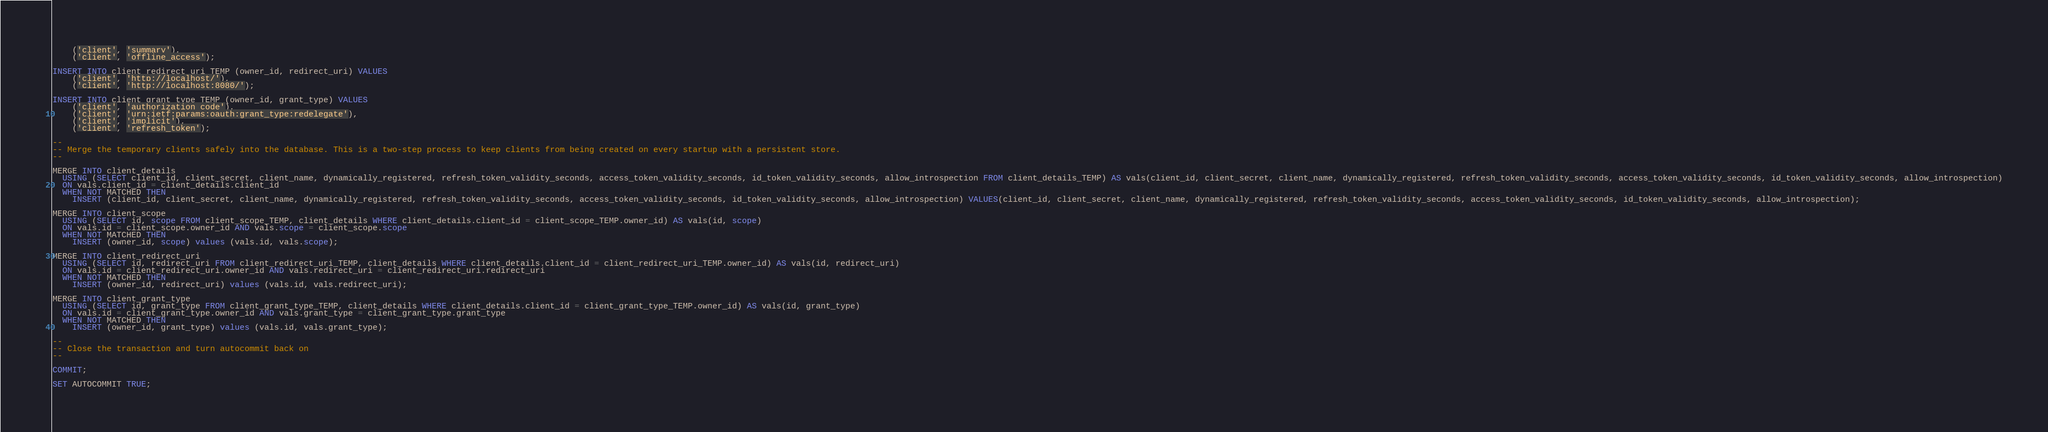Convert code to text. <code><loc_0><loc_0><loc_500><loc_500><_SQL_>	('client', 'summary'),
	('client', 'offline_access');

INSERT INTO client_redirect_uri_TEMP (owner_id, redirect_uri) VALUES
	('client', 'http://localhost/'),
	('client', 'http://localhost:8080/');
	
INSERT INTO client_grant_type_TEMP (owner_id, grant_type) VALUES
	('client', 'authorization_code'),
	('client', 'urn:ietf:params:oauth:grant_type:redelegate'),
	('client', 'implicit'),
	('client', 'refresh_token');
	
--
-- Merge the temporary clients safely into the database. This is a two-step process to keep clients from being created on every startup with a persistent store.
--

MERGE INTO client_details 
  USING (SELECT client_id, client_secret, client_name, dynamically_registered, refresh_token_validity_seconds, access_token_validity_seconds, id_token_validity_seconds, allow_introspection FROM client_details_TEMP) AS vals(client_id, client_secret, client_name, dynamically_registered, refresh_token_validity_seconds, access_token_validity_seconds, id_token_validity_seconds, allow_introspection)
  ON vals.client_id = client_details.client_id
  WHEN NOT MATCHED THEN 
    INSERT (client_id, client_secret, client_name, dynamically_registered, refresh_token_validity_seconds, access_token_validity_seconds, id_token_validity_seconds, allow_introspection) VALUES(client_id, client_secret, client_name, dynamically_registered, refresh_token_validity_seconds, access_token_validity_seconds, id_token_validity_seconds, allow_introspection);

MERGE INTO client_scope 
  USING (SELECT id, scope FROM client_scope_TEMP, client_details WHERE client_details.client_id = client_scope_TEMP.owner_id) AS vals(id, scope)
  ON vals.id = client_scope.owner_id AND vals.scope = client_scope.scope
  WHEN NOT MATCHED THEN 
    INSERT (owner_id, scope) values (vals.id, vals.scope);

MERGE INTO client_redirect_uri 
  USING (SELECT id, redirect_uri FROM client_redirect_uri_TEMP, client_details WHERE client_details.client_id = client_redirect_uri_TEMP.owner_id) AS vals(id, redirect_uri)
  ON vals.id = client_redirect_uri.owner_id AND vals.redirect_uri = client_redirect_uri.redirect_uri
  WHEN NOT MATCHED THEN 
    INSERT (owner_id, redirect_uri) values (vals.id, vals.redirect_uri);

MERGE INTO client_grant_type 
  USING (SELECT id, grant_type FROM client_grant_type_TEMP, client_details WHERE client_details.client_id = client_grant_type_TEMP.owner_id) AS vals(id, grant_type)
  ON vals.id = client_grant_type.owner_id AND vals.grant_type = client_grant_type.grant_type
  WHEN NOT MATCHED THEN 
    INSERT (owner_id, grant_type) values (vals.id, vals.grant_type);
    
-- 
-- Close the transaction and turn autocommit back on
-- 
    
COMMIT;

SET AUTOCOMMIT TRUE;

</code> 